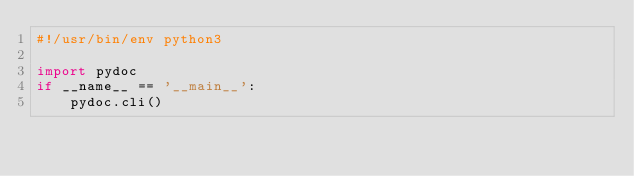<code> <loc_0><loc_0><loc_500><loc_500><_Python_>#!/usr/bin/env python3

import pydoc
if __name__ == '__main__':
    pydoc.cli()
</code> 